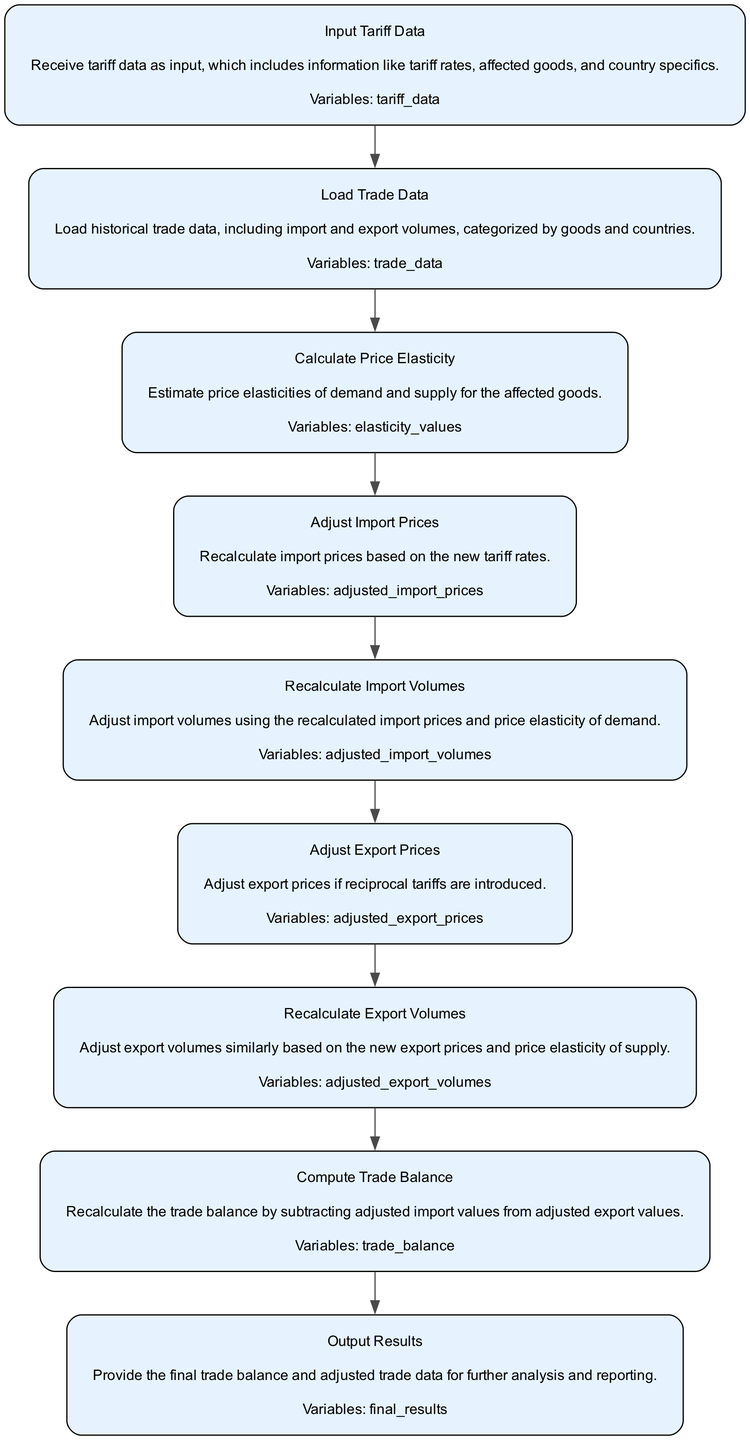What is the first step in the flowchart? The first step is "Input Tariff Data," which signifies that the process begins with receiving tariff data as input.
Answer: Input Tariff Data How many nodes are in the diagram? By counting all the sequential steps listed, we can see there are a total of 9 nodes in the flowchart.
Answer: 9 What step comes after "Load Trade Data"? The next step after "Load Trade Data" is "Calculate Price Elasticity," indicating that after loading trade data, the function estimates price elasticities.
Answer: Calculate Price Elasticity Which step involves adjusting export prices? The process involves adjusting export prices in the step called "Adjust Export Prices."
Answer: Adjust Export Prices How is the trade balance recalculated? The trade balance is recalculated in the "Compute Trade Balance" step, which involves subtracting adjusted import values from adjusted export values.
Answer: Compute Trade Balance What description follows "Adjust Import Prices"? Following "Adjust Import Prices," the description is "Recalculate import volumes using the recalculated import prices and price elasticity of demand."
Answer: Recalculate import volumes using the recalculated import prices and price elasticity of demand Why is "Output Results" considered the last step? "Output Results" is the last step because it aggregates all previous calculations to output the final trade balance and adjusted trade data for further analysis.
Answer: Output Results In which step is price elasticity of supply considered? Price elasticity of supply is considered in the "Recalculate Export Volumes" step.
Answer: Recalculate Export Volumes What are the input parameters required at the beginning? The input parameters required at the beginning are "tariff data" needed to initiate the process.
Answer: tariff data 